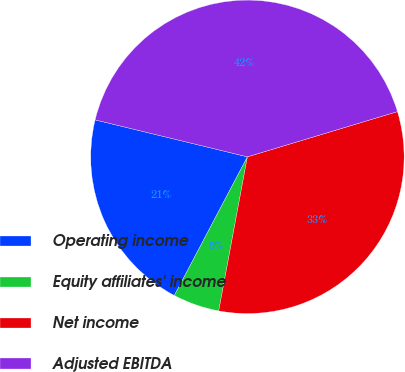<chart> <loc_0><loc_0><loc_500><loc_500><pie_chart><fcel>Operating income<fcel>Equity affiliates' income<fcel>Net income<fcel>Adjusted EBITDA<nl><fcel>21.07%<fcel>4.79%<fcel>32.59%<fcel>41.55%<nl></chart> 